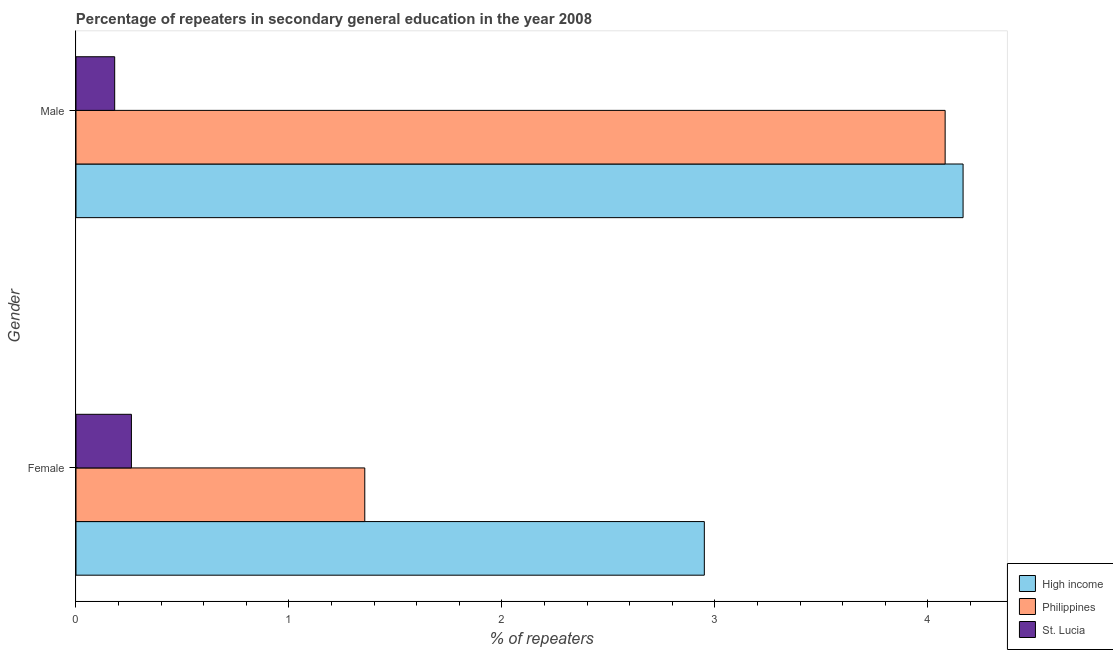How many different coloured bars are there?
Provide a succinct answer. 3. How many groups of bars are there?
Your answer should be very brief. 2. Are the number of bars on each tick of the Y-axis equal?
Keep it short and to the point. Yes. How many bars are there on the 1st tick from the top?
Offer a very short reply. 3. What is the label of the 2nd group of bars from the top?
Give a very brief answer. Female. What is the percentage of female repeaters in Philippines?
Offer a terse response. 1.36. Across all countries, what is the maximum percentage of male repeaters?
Provide a short and direct response. 4.17. Across all countries, what is the minimum percentage of female repeaters?
Keep it short and to the point. 0.26. In which country was the percentage of male repeaters minimum?
Make the answer very short. St. Lucia. What is the total percentage of male repeaters in the graph?
Make the answer very short. 8.43. What is the difference between the percentage of male repeaters in Philippines and that in St. Lucia?
Give a very brief answer. 3.9. What is the difference between the percentage of female repeaters in Philippines and the percentage of male repeaters in St. Lucia?
Provide a short and direct response. 1.17. What is the average percentage of female repeaters per country?
Provide a succinct answer. 1.52. What is the difference between the percentage of male repeaters and percentage of female repeaters in Philippines?
Offer a terse response. 2.73. In how many countries, is the percentage of male repeaters greater than 2 %?
Your answer should be compact. 2. What is the ratio of the percentage of male repeaters in St. Lucia to that in Philippines?
Give a very brief answer. 0.04. Is the percentage of male repeaters in St. Lucia less than that in High income?
Make the answer very short. Yes. In how many countries, is the percentage of female repeaters greater than the average percentage of female repeaters taken over all countries?
Keep it short and to the point. 1. What does the 3rd bar from the bottom in Male represents?
Offer a terse response. St. Lucia. How many countries are there in the graph?
Give a very brief answer. 3. Does the graph contain grids?
Ensure brevity in your answer.  No. Where does the legend appear in the graph?
Give a very brief answer. Bottom right. How many legend labels are there?
Your answer should be compact. 3. What is the title of the graph?
Your answer should be very brief. Percentage of repeaters in secondary general education in the year 2008. What is the label or title of the X-axis?
Offer a terse response. % of repeaters. What is the label or title of the Y-axis?
Ensure brevity in your answer.  Gender. What is the % of repeaters of High income in Female?
Keep it short and to the point. 2.95. What is the % of repeaters of Philippines in Female?
Offer a terse response. 1.36. What is the % of repeaters of St. Lucia in Female?
Your response must be concise. 0.26. What is the % of repeaters in High income in Male?
Keep it short and to the point. 4.17. What is the % of repeaters in Philippines in Male?
Your answer should be compact. 4.08. What is the % of repeaters in St. Lucia in Male?
Ensure brevity in your answer.  0.18. Across all Gender, what is the maximum % of repeaters in High income?
Offer a very short reply. 4.17. Across all Gender, what is the maximum % of repeaters in Philippines?
Give a very brief answer. 4.08. Across all Gender, what is the maximum % of repeaters in St. Lucia?
Give a very brief answer. 0.26. Across all Gender, what is the minimum % of repeaters in High income?
Your answer should be compact. 2.95. Across all Gender, what is the minimum % of repeaters of Philippines?
Give a very brief answer. 1.36. Across all Gender, what is the minimum % of repeaters in St. Lucia?
Offer a terse response. 0.18. What is the total % of repeaters in High income in the graph?
Your answer should be compact. 7.12. What is the total % of repeaters of Philippines in the graph?
Your response must be concise. 5.44. What is the total % of repeaters of St. Lucia in the graph?
Offer a terse response. 0.44. What is the difference between the % of repeaters in High income in Female and that in Male?
Provide a succinct answer. -1.21. What is the difference between the % of repeaters of Philippines in Female and that in Male?
Make the answer very short. -2.73. What is the difference between the % of repeaters in St. Lucia in Female and that in Male?
Provide a short and direct response. 0.08. What is the difference between the % of repeaters of High income in Female and the % of repeaters of Philippines in Male?
Offer a terse response. -1.13. What is the difference between the % of repeaters in High income in Female and the % of repeaters in St. Lucia in Male?
Keep it short and to the point. 2.77. What is the difference between the % of repeaters of Philippines in Female and the % of repeaters of St. Lucia in Male?
Provide a short and direct response. 1.17. What is the average % of repeaters of High income per Gender?
Give a very brief answer. 3.56. What is the average % of repeaters of Philippines per Gender?
Make the answer very short. 2.72. What is the average % of repeaters in St. Lucia per Gender?
Make the answer very short. 0.22. What is the difference between the % of repeaters in High income and % of repeaters in Philippines in Female?
Provide a short and direct response. 1.59. What is the difference between the % of repeaters in High income and % of repeaters in St. Lucia in Female?
Ensure brevity in your answer.  2.69. What is the difference between the % of repeaters of Philippines and % of repeaters of St. Lucia in Female?
Offer a very short reply. 1.1. What is the difference between the % of repeaters in High income and % of repeaters in Philippines in Male?
Make the answer very short. 0.08. What is the difference between the % of repeaters in High income and % of repeaters in St. Lucia in Male?
Give a very brief answer. 3.98. What is the difference between the % of repeaters in Philippines and % of repeaters in St. Lucia in Male?
Your answer should be compact. 3.9. What is the ratio of the % of repeaters of High income in Female to that in Male?
Your answer should be compact. 0.71. What is the ratio of the % of repeaters in Philippines in Female to that in Male?
Give a very brief answer. 0.33. What is the ratio of the % of repeaters in St. Lucia in Female to that in Male?
Give a very brief answer. 1.43. What is the difference between the highest and the second highest % of repeaters of High income?
Your response must be concise. 1.21. What is the difference between the highest and the second highest % of repeaters in Philippines?
Offer a very short reply. 2.73. What is the difference between the highest and the second highest % of repeaters in St. Lucia?
Make the answer very short. 0.08. What is the difference between the highest and the lowest % of repeaters of High income?
Provide a short and direct response. 1.21. What is the difference between the highest and the lowest % of repeaters of Philippines?
Offer a very short reply. 2.73. What is the difference between the highest and the lowest % of repeaters of St. Lucia?
Keep it short and to the point. 0.08. 